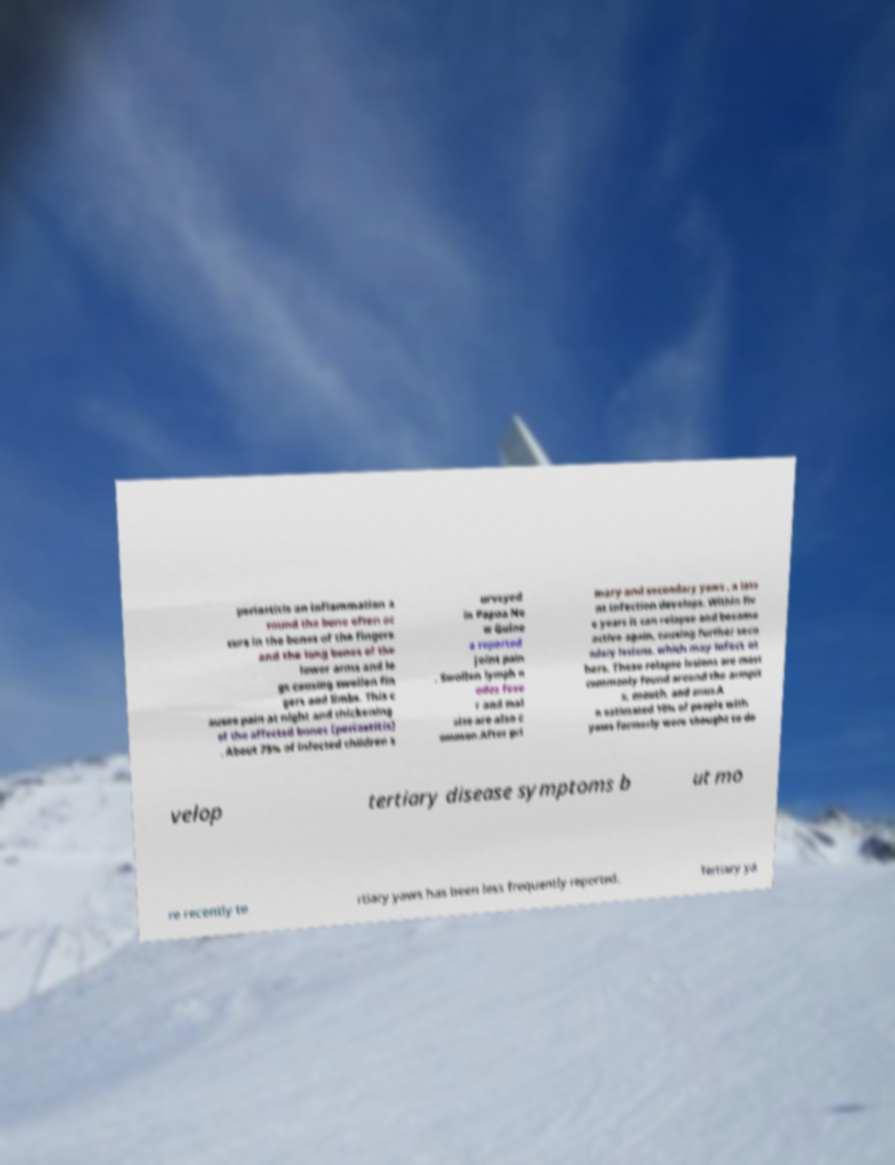Please identify and transcribe the text found in this image. periostitis an inflammation a round the bone often oc curs in the bones of the fingers and the long bones of the lower arms and le gs causing swollen fin gers and limbs. This c auses pain at night and thickening of the affected bones (periostitis) . About 75% of infected children s urveyed in Papua Ne w Guine a reported joint pain . Swollen lymph n odes feve r and mal aise are also c ommon.After pri mary and secondary yaws , a late nt infection develops. Within fiv e years it can relapse and become active again, causing further seco ndary lesions, which may infect ot hers. These relapse lesions are most commonly found around the armpit s, mouth, and anus.A n estimated 10% of people with yaws formerly were thought to de velop tertiary disease symptoms b ut mo re recently te rtiary yaws has been less frequently reported. Tertiary ya 